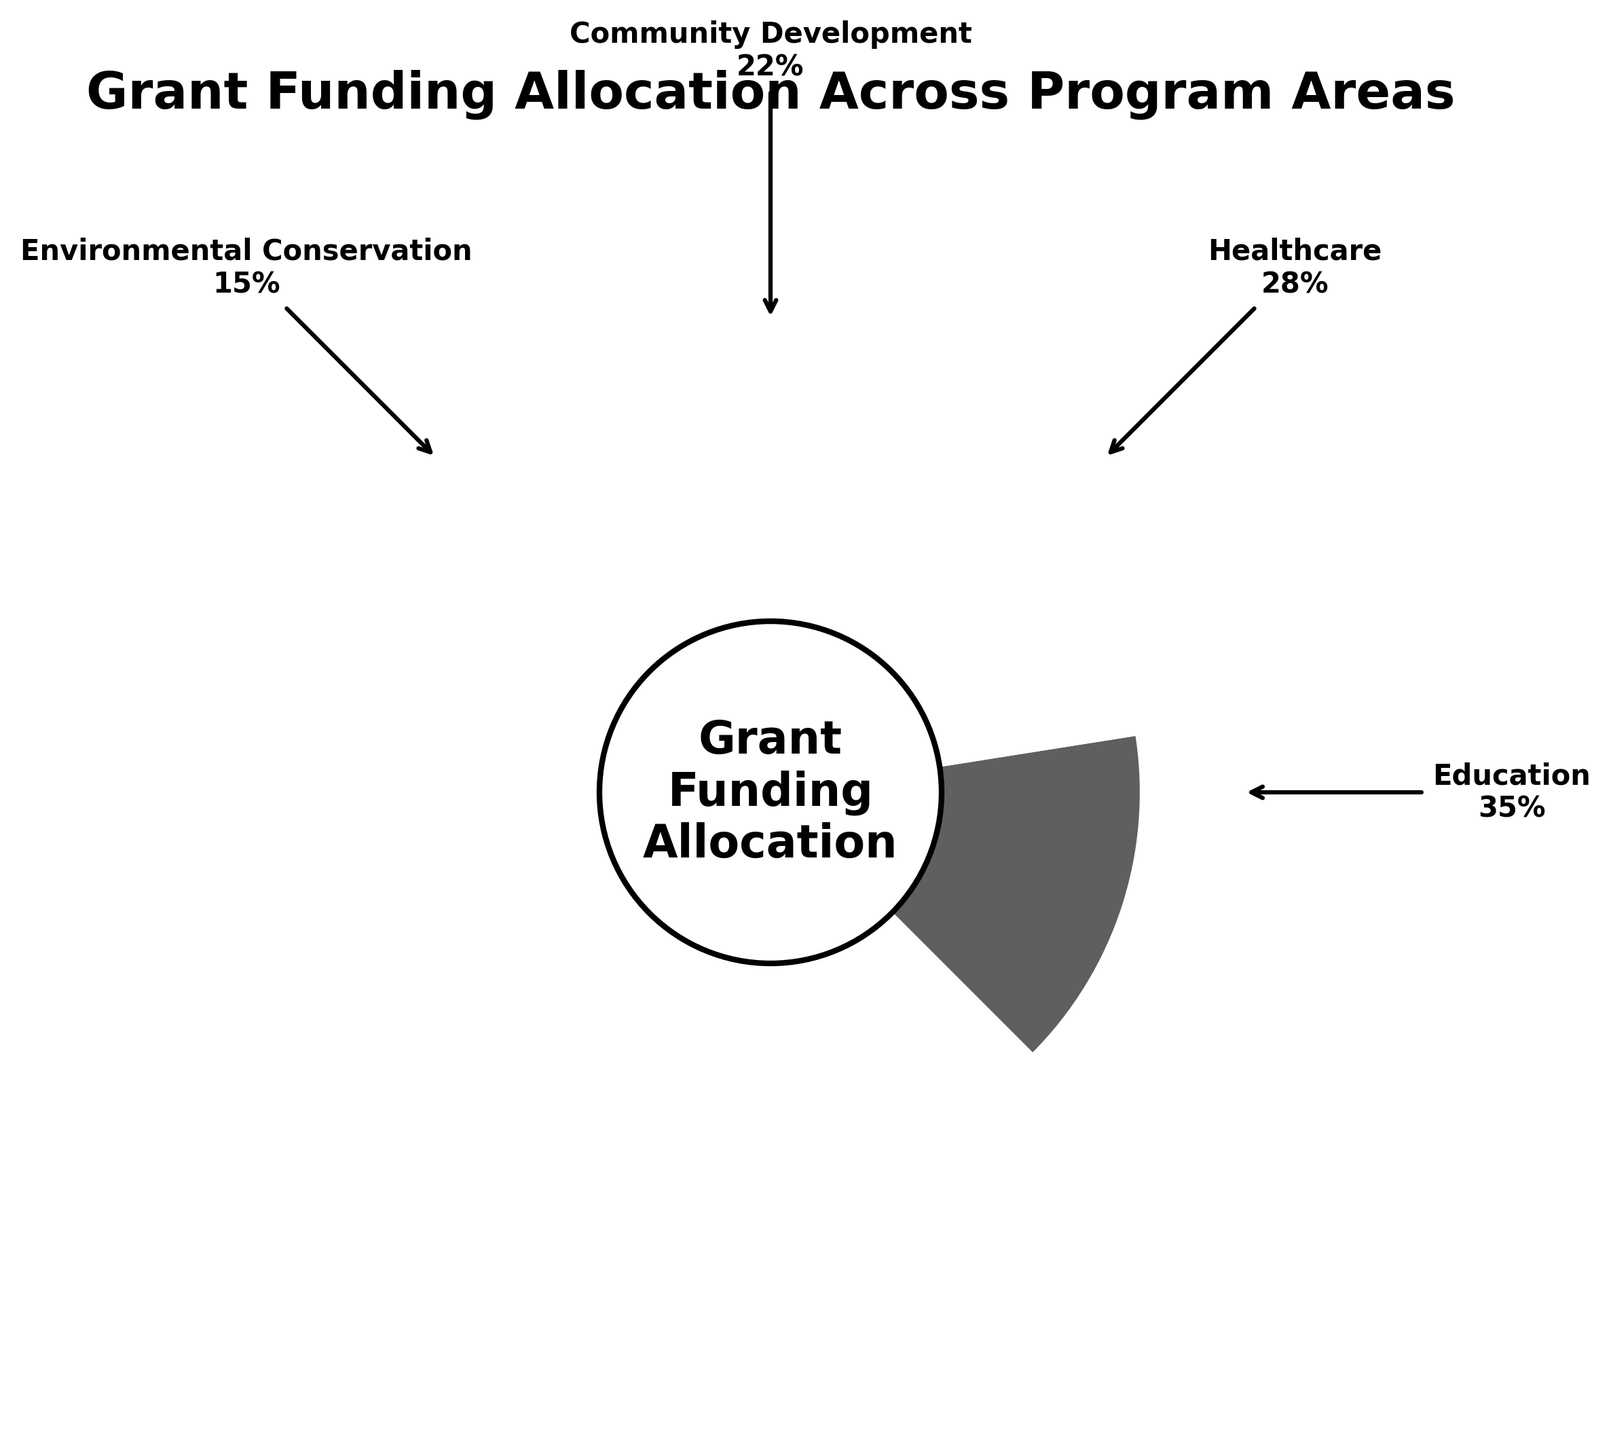How many program areas are displayed in the gauge chart? The gauge chart displays the program areas indicated by the wedges. Count the number of unique labeled wedges.
Answer: 4 What is the percentage allocation for the Healthcare program area? Look for the label "Healthcare" on the chart and read the percentage value next to it.
Answer: 28% Which program area received the highest percentage of funding? Identify the wedge with the largest percentage value among all the labeled program areas.
Answer: Education What is the sum of the percentages for Healthcare and Environmental Conservation program areas? Locate the percentage values for 'Healthcare' and 'Environmental Conservation' and add them together (28% + 15%).
Answer: 43% How much more funding (in percentage points) does Education receive compared to Community Development? Find the percentage values for 'Education' and 'Community Development', then subtract the latter from the former (35% - 22%).
Answer: 13% Which program area has the least percentage of funding, and what is its value? Identify the wedge with the smallest percentage value among all labeled areas.
Answer: Environmental Conservation, 15% Are there any program areas that have the same percentage of funding? Compare the percentage values for each program area to see if any two are identical.
Answer: No What is the difference in funding allocated between the most and least funded program areas? Determine the percentage for the highest funded area (Education at 35%) and the least funded area (Environmental Conservation at 15%) and find the difference (35% - 15%).
Answer: 20% If the total funding is 1 million USD, how much funding in USD is allocated to Community Development? First find the percentage for 'Community Development' which is 22%. Calculate 22% of 1 million USD (0.22 * 1,000,000).
Answer: 220,000 USD How are the program areas visually separated in the gauge chart? Check for any visual separators or annotations that divide the sections of the chart, such as distinct wedges or lines.
Answer: By distinct wedges with labeling and coloring 